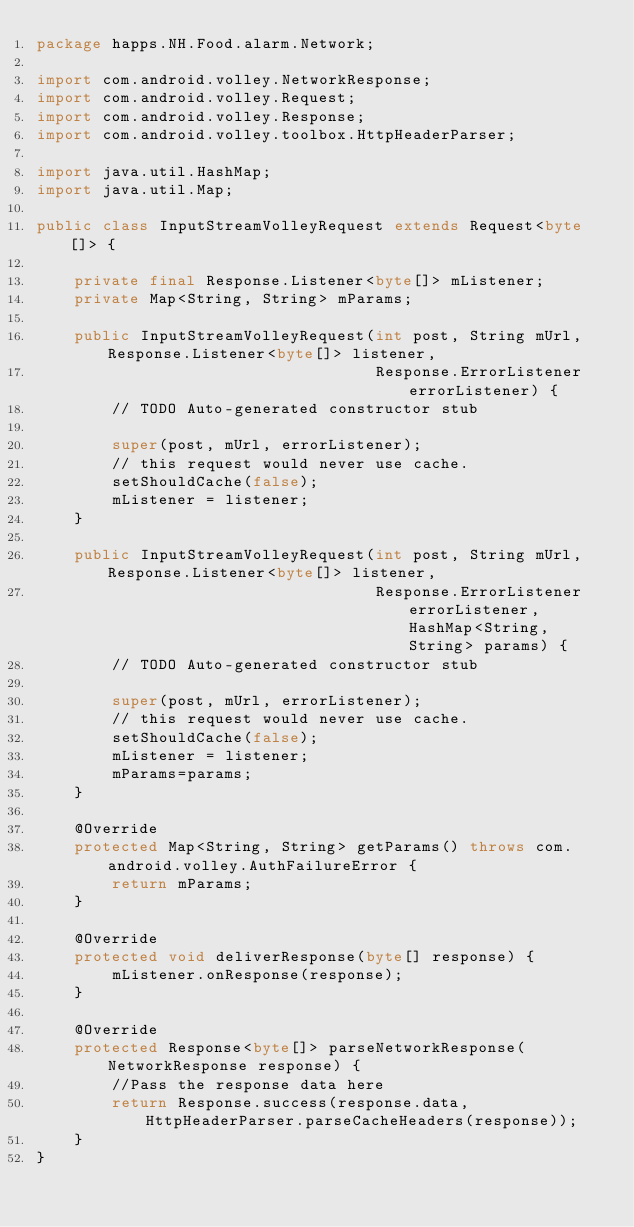Convert code to text. <code><loc_0><loc_0><loc_500><loc_500><_Java_>package happs.NH.Food.alarm.Network;

import com.android.volley.NetworkResponse;
import com.android.volley.Request;
import com.android.volley.Response;
import com.android.volley.toolbox.HttpHeaderParser;

import java.util.HashMap;
import java.util.Map;

public class InputStreamVolleyRequest extends Request<byte[]> {

    private final Response.Listener<byte[]> mListener;
    private Map<String, String> mParams;

    public InputStreamVolleyRequest(int post, String mUrl,Response.Listener<byte[]> listener,
                                    Response.ErrorListener errorListener) {
        // TODO Auto-generated constructor stub

        super(post, mUrl, errorListener);
        // this request would never use cache.
        setShouldCache(false);
        mListener = listener;
    }

    public InputStreamVolleyRequest(int post, String mUrl,Response.Listener<byte[]> listener,
                                    Response.ErrorListener errorListener, HashMap<String, String> params) {
        // TODO Auto-generated constructor stub

        super(post, mUrl, errorListener);
        // this request would never use cache.
        setShouldCache(false);
        mListener = listener;
        mParams=params;
    }

    @Override
    protected Map<String, String> getParams() throws com.android.volley.AuthFailureError {
        return mParams;
    }

    @Override
    protected void deliverResponse(byte[] response) {
        mListener.onResponse(response);
    }

    @Override
    protected Response<byte[]> parseNetworkResponse(NetworkResponse response) {
        //Pass the response data here
        return Response.success(response.data, HttpHeaderParser.parseCacheHeaders(response));
    }
}
</code> 